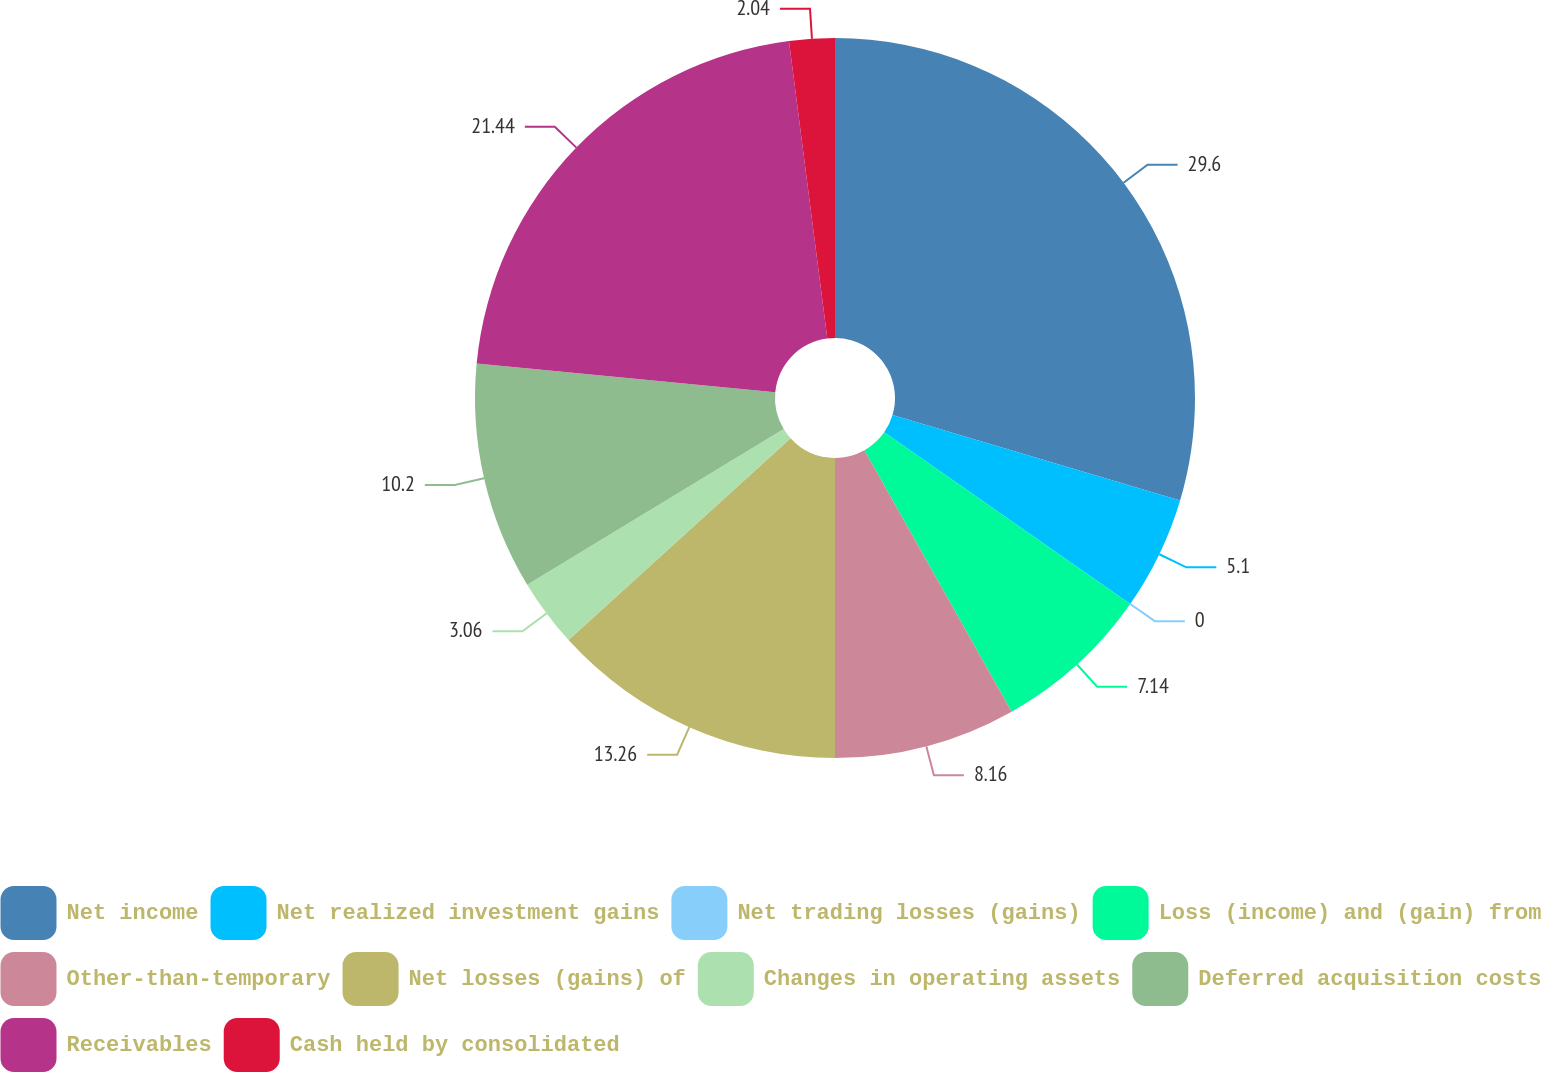Convert chart. <chart><loc_0><loc_0><loc_500><loc_500><pie_chart><fcel>Net income<fcel>Net realized investment gains<fcel>Net trading losses (gains)<fcel>Loss (income) and (gain) from<fcel>Other-than-temporary<fcel>Net losses (gains) of<fcel>Changes in operating assets<fcel>Deferred acquisition costs<fcel>Receivables<fcel>Cash held by consolidated<nl><fcel>29.59%<fcel>5.1%<fcel>0.0%<fcel>7.14%<fcel>8.16%<fcel>13.26%<fcel>3.06%<fcel>10.2%<fcel>21.43%<fcel>2.04%<nl></chart> 